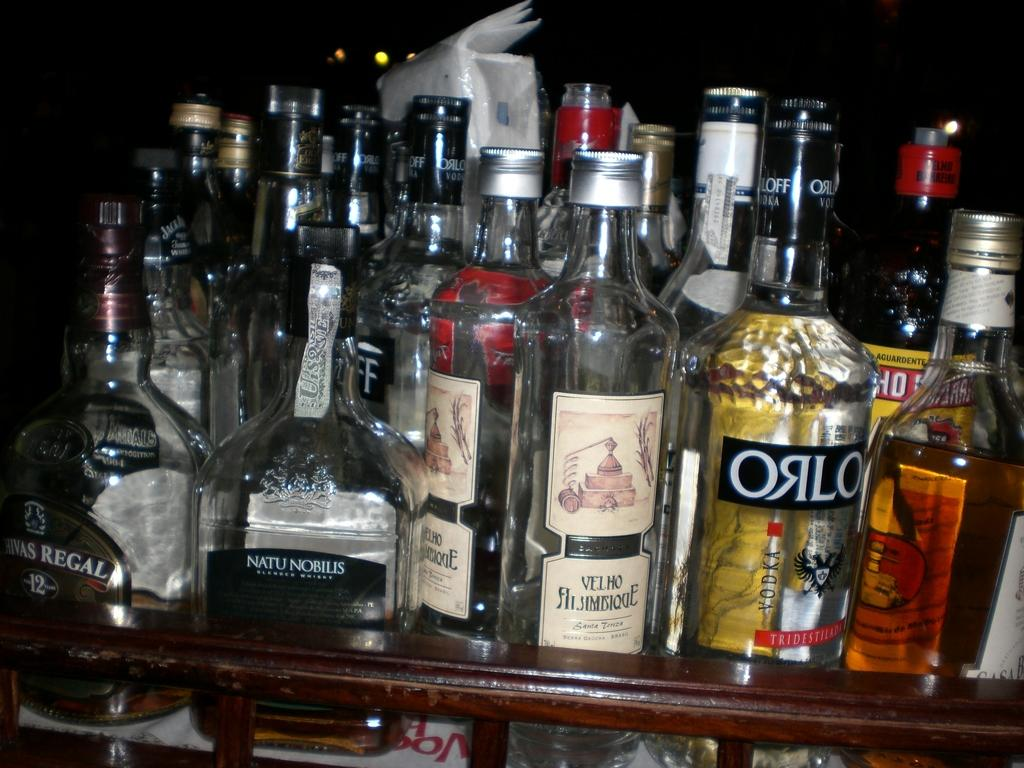What type of bottles can be seen in the image? There are several wine bottles in the image. Can you describe the contents of the wine bottles? Some of the wine bottles are partially filled, while others are completely filled. What type of kettle is used to polish the toys in the image? There is no kettle or toys present in the image; it only features wine bottles. 